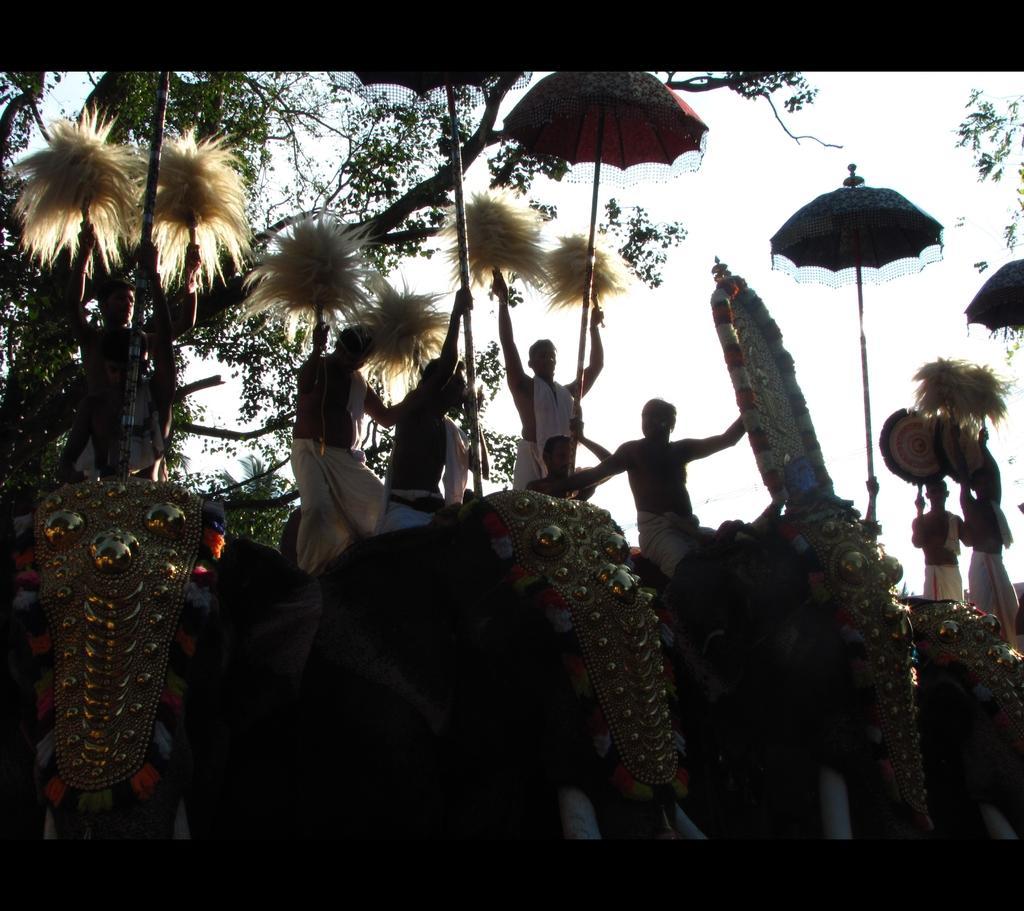Describe this image in one or two sentences. This is the picture of a place where we have some elephants on which there are some people holding some things and umbrellas and around there are some trees and plants. 